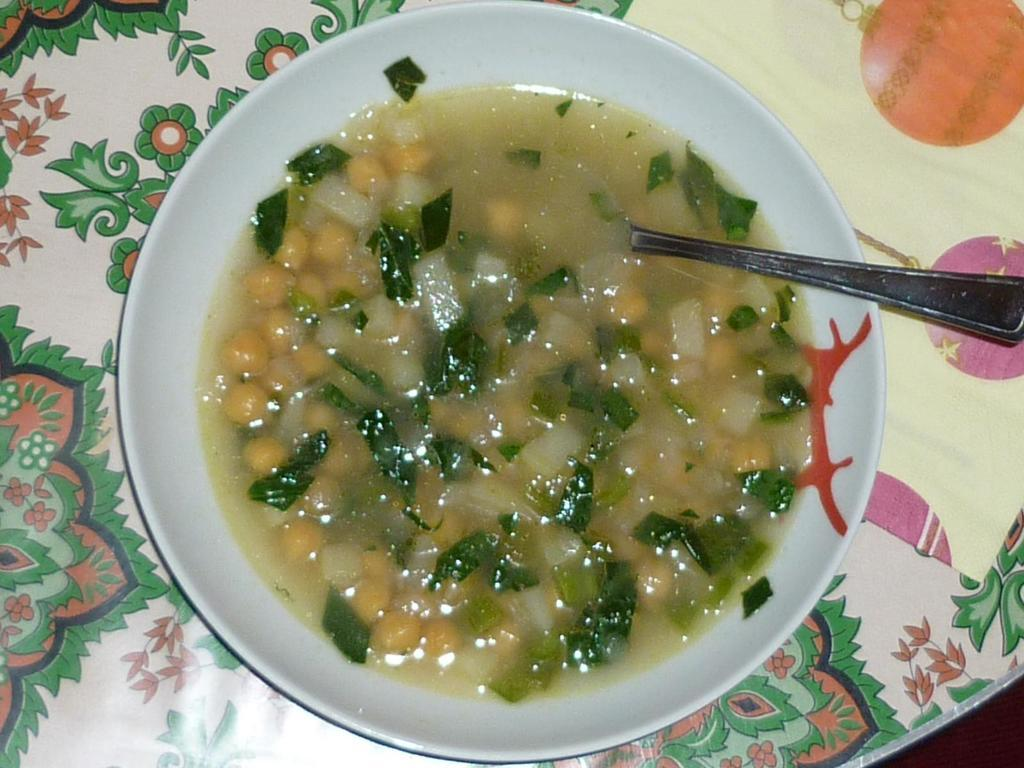What is in the bowl that is visible in the image? There is a bowl of soup in the image. What utensil is present in the bowl? There is a spoon in the bowl. Where is the spoon located in the bowl? The spoon is in the center of the bowl. What type of spy equipment can be seen in the image? There is no spy equipment present in the image; it features a bowl of soup with a spoon in the center. How many flies are visible in the image? There are no flies present in the image. 